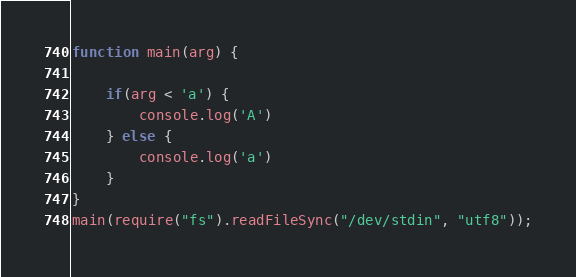Convert code to text. <code><loc_0><loc_0><loc_500><loc_500><_JavaScript_>function main(arg) {
	
  	if(arg < 'a') {
        console.log('A')
    } else {
        console.log('a')
    }
}
main(require("fs").readFileSync("/dev/stdin", "utf8"));</code> 